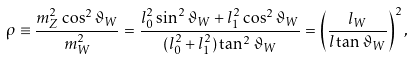Convert formula to latex. <formula><loc_0><loc_0><loc_500><loc_500>\rho \equiv \frac { m _ { Z } ^ { 2 } \cos ^ { 2 } \vartheta _ { W } } { m _ { W } ^ { 2 } } = \frac { l _ { 0 } ^ { 2 } \sin ^ { 2 } \vartheta _ { W } + l _ { 1 } ^ { 2 } \cos ^ { 2 } \vartheta _ { W } } { ( l _ { 0 } ^ { 2 } + l _ { 1 } ^ { 2 } ) \tan ^ { 2 } \vartheta _ { W } } = \left ( \frac { l _ { W } } { l \tan \vartheta _ { W } } \right ) ^ { 2 } ,</formula> 